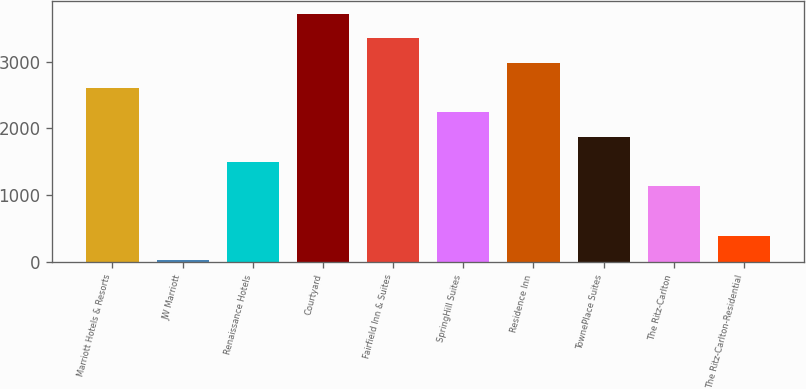<chart> <loc_0><loc_0><loc_500><loc_500><bar_chart><fcel>Marriott Hotels & Resorts<fcel>JW Marriott<fcel>Renaissance Hotels<fcel>Courtyard<fcel>Fairfield Inn & Suites<fcel>SpringHill Suites<fcel>Residence Inn<fcel>TownePlace Suites<fcel>The Ritz-Carlton<fcel>The Ritz-Carlton-Residential<nl><fcel>2609.2<fcel>22<fcel>1500.4<fcel>3718<fcel>3348.4<fcel>2239.6<fcel>2978.8<fcel>1870<fcel>1130.8<fcel>391.6<nl></chart> 